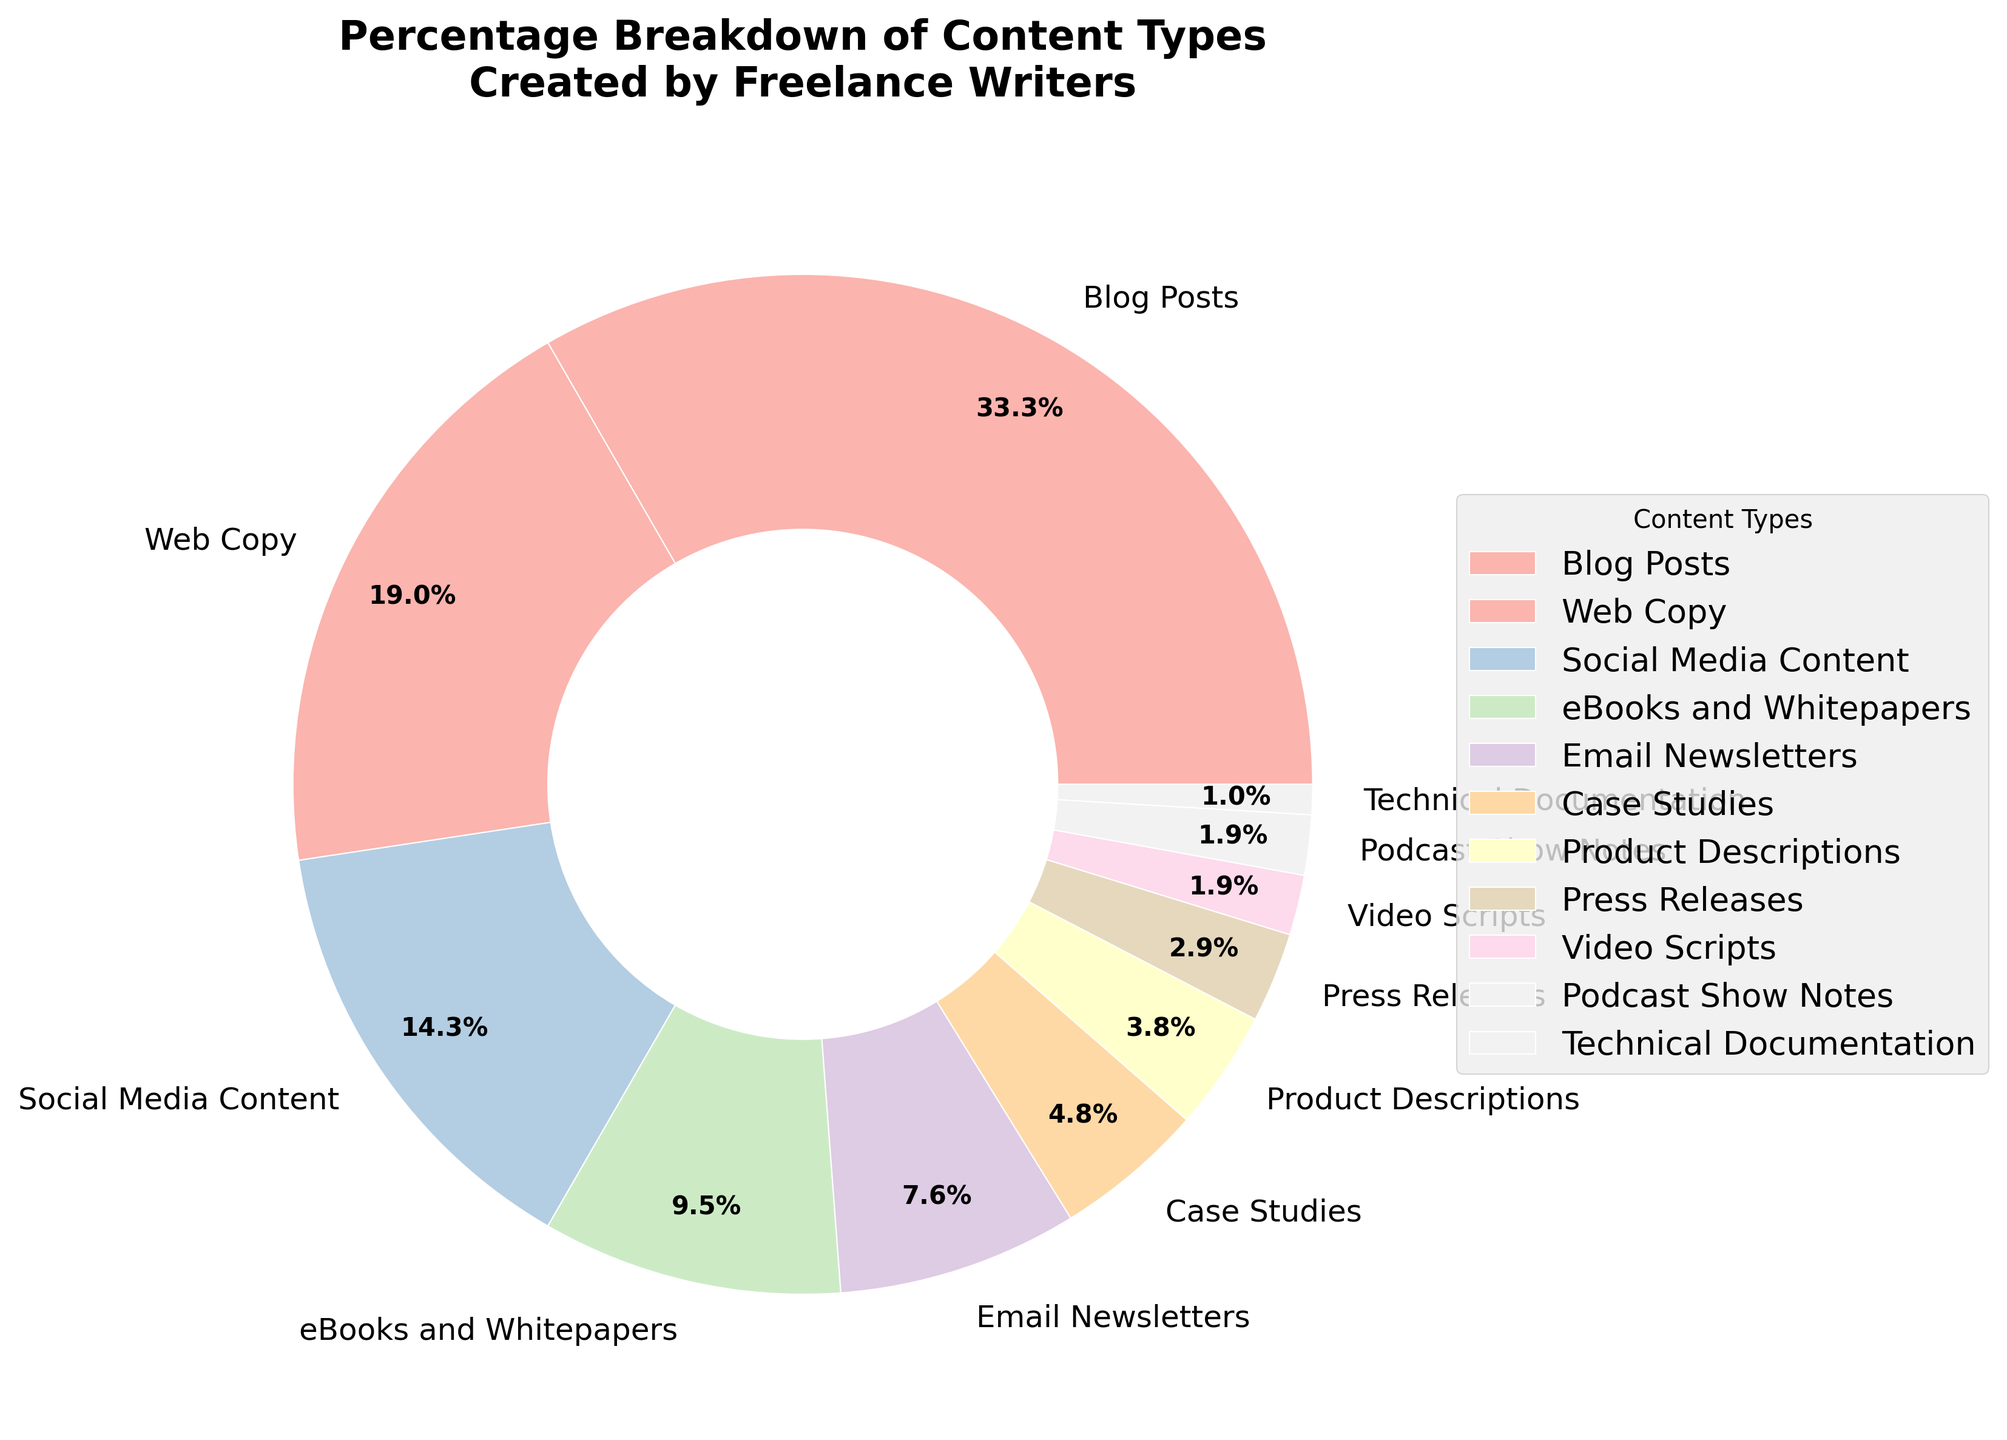What percentage of the content types do Blog Posts, Web Copy, and Social Media Content together account for? To find the combined percentage, you sum up the percentages of Blog Posts (35%), Web Copy (20%), and Social Media Content (15%). The sum is 35 + 20 + 15 = 70%.
Answer: 70% Which content type has the smallest percentage and what is that percentage? By examining the pie chart, one can see that Technical Documentation has the smallest slice. The percentage for Technical Documentation is 1%.
Answer: Technical Documentation, 1% Are Email Newsletters more common than Case Studies? If so, by how much? Compare the percentages of Email Newsletters (8%) and Case Studies (5%). Email Newsletters are more common by 8 - 5 = 3%.
Answer: Yes, by 3% Which content type has a percentage corresponding to 10%, and could it be described by its visual color? The pie chart's legend indicates that eBooks and Whitepapers have a percentage of 10%. The color used to represent eBooks and Whitepapers on the pie chart should be specified by the chart's color scheme.
Answer: eBooks and Whitepapers, color according to scheme What is the combined percentage of all content types that have a percentage less than 5%? Adding up the percentages: Product Descriptions (4%), Press Releases (3%), Video Scripts (2%), Podcast Show Notes (2%), Technical Documentation (1%). The sum is 4 + 3 + 2 + 2 + 1 = 12%.
Answer: 12% Which is more prevalent, Web Copy or Social Media Content? Web Copy has a percentage of 20%, while Social Media Content has a percentage of 15%. Therefore, Web Copy is more prevalent.
Answer: Web Copy What is the overall percentage of content types used for marketing and advertising purposes (consider Blog Posts, Web Copy, Social Media Content, and Email Newsletters)? Summing the percentages of Blog Posts (35%), Web Copy (20%), Social Media Content (15%), and Email Newsletters (8%) gives 35 + 20 + 15 + 8 = 78%.
Answer: 78% How many content types have percentages greater than or equal to 10%? By examining the pie chart, we can see that Blog Posts (35%), Web Copy (20%), and Social Media Content (15%) are each greater than or equal to 10%. eBooks and Whitepapers (10%) precisely meet the 10% threshold. Hence, there are 4 such content types.
Answer: 4 Which content type occupies the largest slice on the chart, and what is its significance? The largest slice on the pie chart represents Blog Posts. With a percentage of 35%, it signifies that Blog Posts are the most commonly created content by freelance writers according to the data shown.
Answer: Blog Posts, largest How does the percentage of Case Studies compare to the percentage of Video Scripts? The percentage for Case Studies is 5%, while for Video Scripts, it is 2%. Therefore, Case Studies are more prevalent.
Answer: Case Studies are more prevalent by 3% 